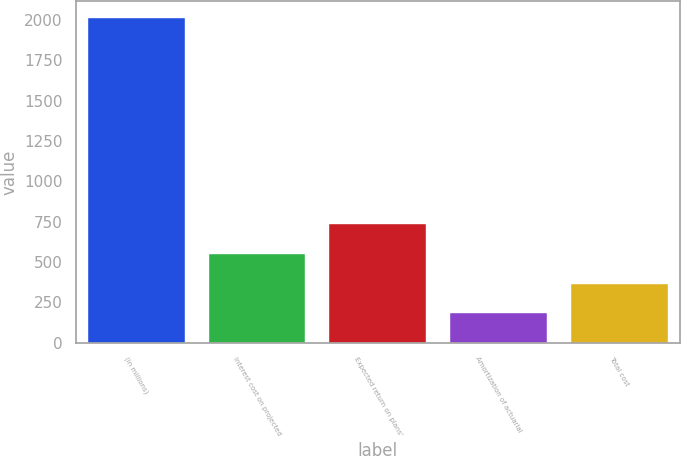Convert chart. <chart><loc_0><loc_0><loc_500><loc_500><bar_chart><fcel>(in millions)<fcel>Interest cost on projected<fcel>Expected return on plans'<fcel>Amortization of actuarial<fcel>Total cost<nl><fcel>2015<fcel>550.2<fcel>733.3<fcel>184<fcel>367.1<nl></chart> 